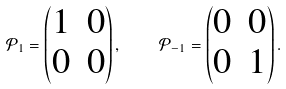<formula> <loc_0><loc_0><loc_500><loc_500>\mathcal { P } _ { 1 } = \begin{pmatrix} 1 & 0 \\ 0 & 0 \end{pmatrix} , \quad \mathcal { P } _ { - 1 } = \begin{pmatrix} 0 & 0 \\ 0 & 1 \end{pmatrix} .</formula> 